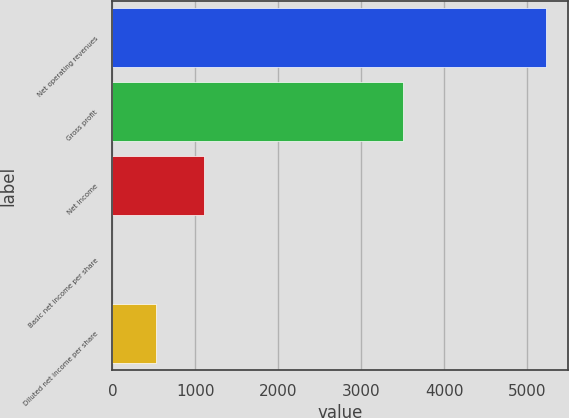<chart> <loc_0><loc_0><loc_500><loc_500><bar_chart><fcel>Net operating revenues<fcel>Gross profit<fcel>Net income<fcel>Basic net income per share<fcel>Diluted net income per share<nl><fcel>5226<fcel>3500<fcel>1106<fcel>0.47<fcel>523.02<nl></chart> 